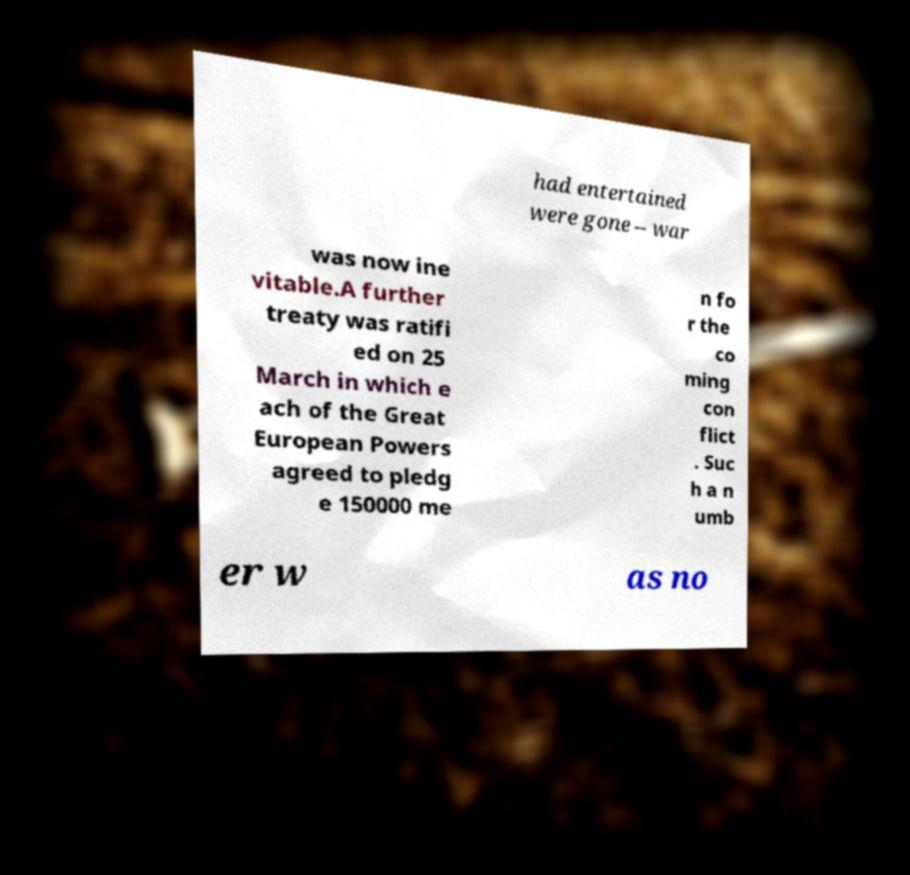Please read and relay the text visible in this image. What does it say? had entertained were gone – war was now ine vitable.A further treaty was ratifi ed on 25 March in which e ach of the Great European Powers agreed to pledg e 150000 me n fo r the co ming con flict . Suc h a n umb er w as no 